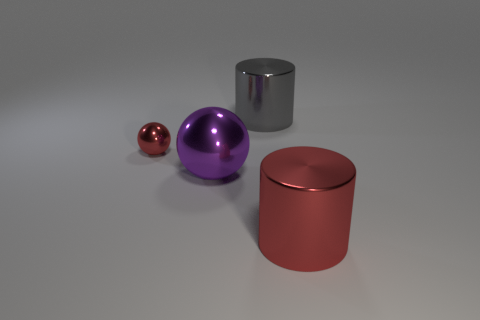There is a sphere that is the same size as the red cylinder; what color is it?
Make the answer very short. Purple. Is the size of the purple metallic object the same as the gray metallic thing?
Offer a terse response. Yes. The other shiny thing that is the same color as the small metal thing is what shape?
Provide a succinct answer. Cylinder. Is the size of the red cylinder the same as the red object left of the large purple metal sphere?
Give a very brief answer. No. What is the color of the big object that is in front of the big gray cylinder and behind the large red metallic thing?
Your response must be concise. Purple. Is the number of small metal balls that are behind the big purple metal object greater than the number of tiny red metallic spheres that are right of the big gray cylinder?
Give a very brief answer. Yes. What size is the red ball that is made of the same material as the large gray thing?
Offer a terse response. Small. How many shiny things are left of the ball that is left of the purple shiny ball?
Offer a very short reply. 0. Are there any other big purple objects of the same shape as the purple thing?
Provide a short and direct response. No. The cylinder that is behind the large thing to the left of the gray shiny cylinder is what color?
Your response must be concise. Gray. 